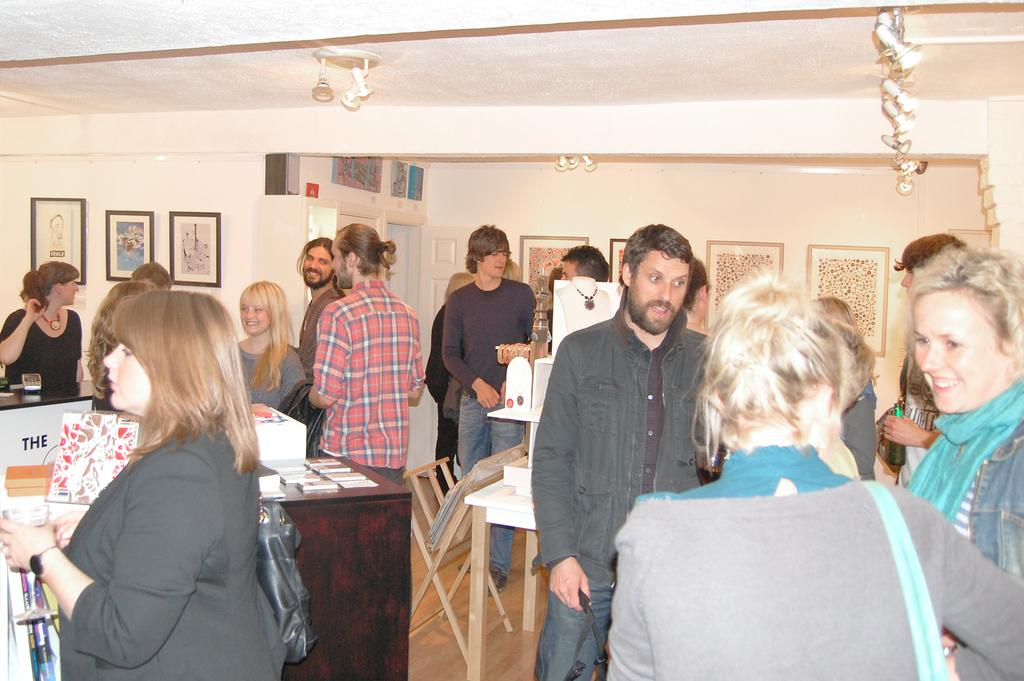What are the people in the image doing? The persons standing on the floor in the image are not engaged in any specific activity. What is the main object in the image besides the people? There is a table in the image. What can be seen in the background of the image? There is a wall in the background of the image, and frames are hung on the wall. What is the surface that the people and table are standing on? The floor is visible in the image. What type of dust can be seen on the scissors in the image? There are no scissors present in the image, so it is not possible to determine if there is any dust on them. 